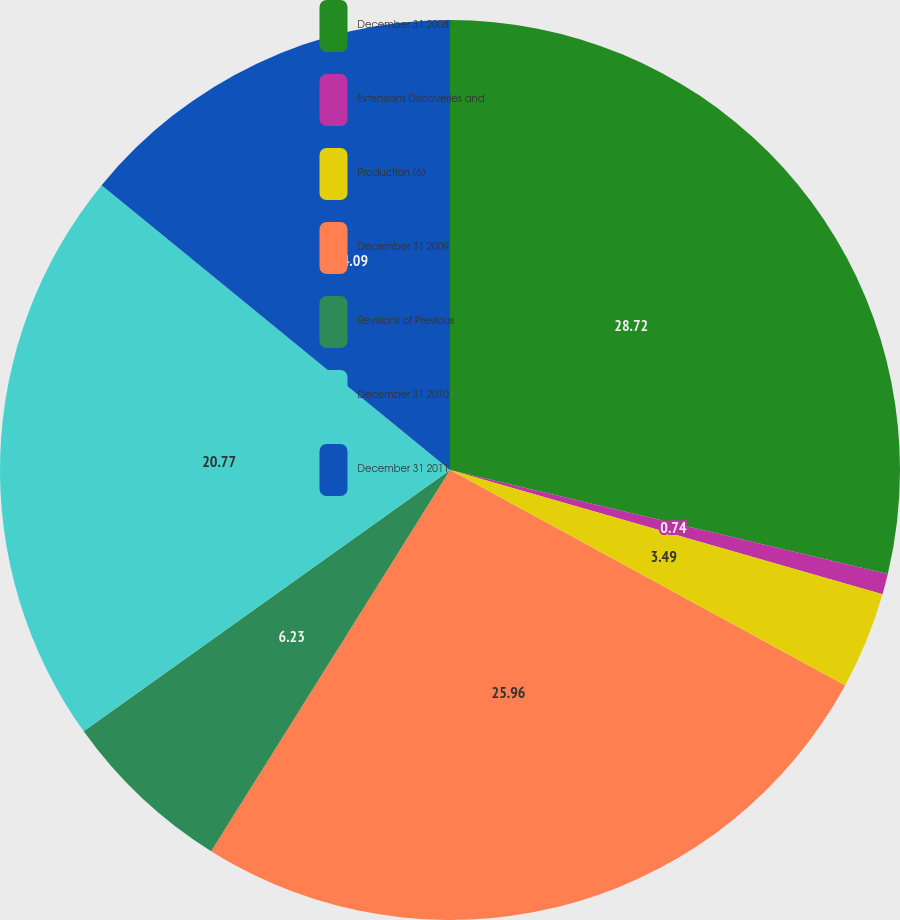<chart> <loc_0><loc_0><loc_500><loc_500><pie_chart><fcel>December 31 2008<fcel>Extensions Discoveries and<fcel>Production (6)<fcel>December 31 2009<fcel>Revisions of Previous<fcel>December 31 2010<fcel>December 31 2011<nl><fcel>28.71%<fcel>0.74%<fcel>3.49%<fcel>25.96%<fcel>6.23%<fcel>20.77%<fcel>14.09%<nl></chart> 